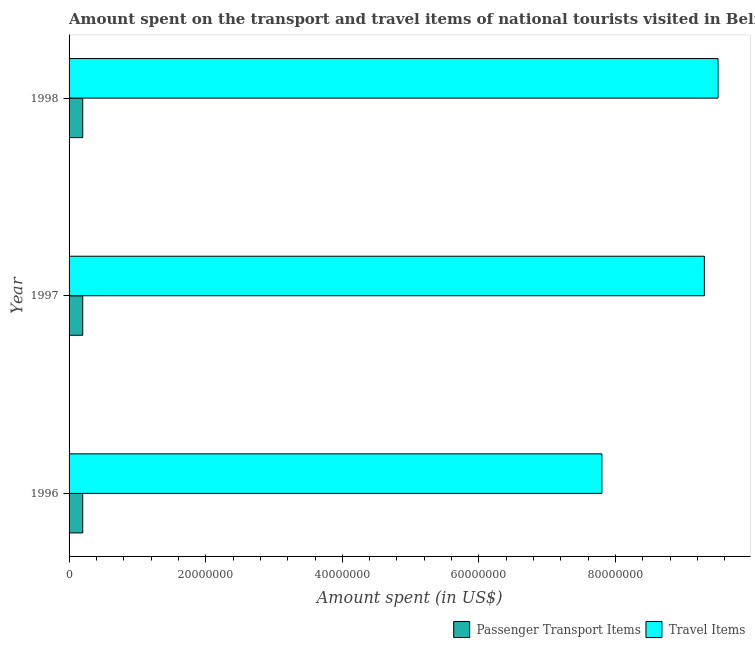Are the number of bars per tick equal to the number of legend labels?
Provide a succinct answer. Yes. Are the number of bars on each tick of the Y-axis equal?
Make the answer very short. Yes. How many bars are there on the 1st tick from the top?
Your answer should be compact. 2. How many bars are there on the 2nd tick from the bottom?
Ensure brevity in your answer.  2. What is the amount spent on passenger transport items in 1998?
Offer a terse response. 2.00e+06. Across all years, what is the maximum amount spent in travel items?
Your answer should be compact. 9.50e+07. Across all years, what is the minimum amount spent on passenger transport items?
Provide a succinct answer. 2.00e+06. What is the total amount spent on passenger transport items in the graph?
Provide a succinct answer. 6.00e+06. What is the difference between the amount spent in travel items in 1997 and the amount spent on passenger transport items in 1996?
Ensure brevity in your answer.  9.10e+07. What is the average amount spent in travel items per year?
Offer a terse response. 8.87e+07. In the year 1997, what is the difference between the amount spent in travel items and amount spent on passenger transport items?
Ensure brevity in your answer.  9.10e+07. In how many years, is the amount spent in travel items greater than 92000000 US$?
Make the answer very short. 2. What is the ratio of the amount spent on passenger transport items in 1997 to that in 1998?
Offer a terse response. 1. Is the amount spent on passenger transport items in 1997 less than that in 1998?
Your answer should be very brief. No. Is the sum of the amount spent in travel items in 1996 and 1997 greater than the maximum amount spent on passenger transport items across all years?
Your answer should be very brief. Yes. What does the 2nd bar from the top in 1998 represents?
Give a very brief answer. Passenger Transport Items. What does the 1st bar from the bottom in 1998 represents?
Your response must be concise. Passenger Transport Items. How many bars are there?
Your answer should be compact. 6. Are all the bars in the graph horizontal?
Ensure brevity in your answer.  Yes. How many years are there in the graph?
Offer a terse response. 3. What is the difference between two consecutive major ticks on the X-axis?
Provide a succinct answer. 2.00e+07. Does the graph contain grids?
Your response must be concise. No. How many legend labels are there?
Your answer should be compact. 2. How are the legend labels stacked?
Offer a very short reply. Horizontal. What is the title of the graph?
Your response must be concise. Amount spent on the transport and travel items of national tourists visited in Belize. What is the label or title of the X-axis?
Offer a terse response. Amount spent (in US$). What is the label or title of the Y-axis?
Your answer should be very brief. Year. What is the Amount spent (in US$) in Travel Items in 1996?
Give a very brief answer. 7.80e+07. What is the Amount spent (in US$) of Travel Items in 1997?
Keep it short and to the point. 9.30e+07. What is the Amount spent (in US$) in Passenger Transport Items in 1998?
Ensure brevity in your answer.  2.00e+06. What is the Amount spent (in US$) in Travel Items in 1998?
Keep it short and to the point. 9.50e+07. Across all years, what is the maximum Amount spent (in US$) of Travel Items?
Ensure brevity in your answer.  9.50e+07. Across all years, what is the minimum Amount spent (in US$) in Passenger Transport Items?
Offer a terse response. 2.00e+06. Across all years, what is the minimum Amount spent (in US$) of Travel Items?
Your answer should be very brief. 7.80e+07. What is the total Amount spent (in US$) of Travel Items in the graph?
Provide a short and direct response. 2.66e+08. What is the difference between the Amount spent (in US$) of Travel Items in 1996 and that in 1997?
Provide a short and direct response. -1.50e+07. What is the difference between the Amount spent (in US$) in Passenger Transport Items in 1996 and that in 1998?
Ensure brevity in your answer.  0. What is the difference between the Amount spent (in US$) of Travel Items in 1996 and that in 1998?
Your response must be concise. -1.70e+07. What is the difference between the Amount spent (in US$) in Passenger Transport Items in 1996 and the Amount spent (in US$) in Travel Items in 1997?
Offer a terse response. -9.10e+07. What is the difference between the Amount spent (in US$) of Passenger Transport Items in 1996 and the Amount spent (in US$) of Travel Items in 1998?
Provide a succinct answer. -9.30e+07. What is the difference between the Amount spent (in US$) in Passenger Transport Items in 1997 and the Amount spent (in US$) in Travel Items in 1998?
Offer a very short reply. -9.30e+07. What is the average Amount spent (in US$) in Passenger Transport Items per year?
Keep it short and to the point. 2.00e+06. What is the average Amount spent (in US$) in Travel Items per year?
Offer a very short reply. 8.87e+07. In the year 1996, what is the difference between the Amount spent (in US$) in Passenger Transport Items and Amount spent (in US$) in Travel Items?
Offer a terse response. -7.60e+07. In the year 1997, what is the difference between the Amount spent (in US$) of Passenger Transport Items and Amount spent (in US$) of Travel Items?
Provide a short and direct response. -9.10e+07. In the year 1998, what is the difference between the Amount spent (in US$) in Passenger Transport Items and Amount spent (in US$) in Travel Items?
Your answer should be very brief. -9.30e+07. What is the ratio of the Amount spent (in US$) of Travel Items in 1996 to that in 1997?
Ensure brevity in your answer.  0.84. What is the ratio of the Amount spent (in US$) in Passenger Transport Items in 1996 to that in 1998?
Ensure brevity in your answer.  1. What is the ratio of the Amount spent (in US$) in Travel Items in 1996 to that in 1998?
Make the answer very short. 0.82. What is the ratio of the Amount spent (in US$) of Travel Items in 1997 to that in 1998?
Your answer should be very brief. 0.98. What is the difference between the highest and the second highest Amount spent (in US$) in Travel Items?
Your answer should be very brief. 2.00e+06. What is the difference between the highest and the lowest Amount spent (in US$) of Passenger Transport Items?
Make the answer very short. 0. What is the difference between the highest and the lowest Amount spent (in US$) in Travel Items?
Offer a very short reply. 1.70e+07. 